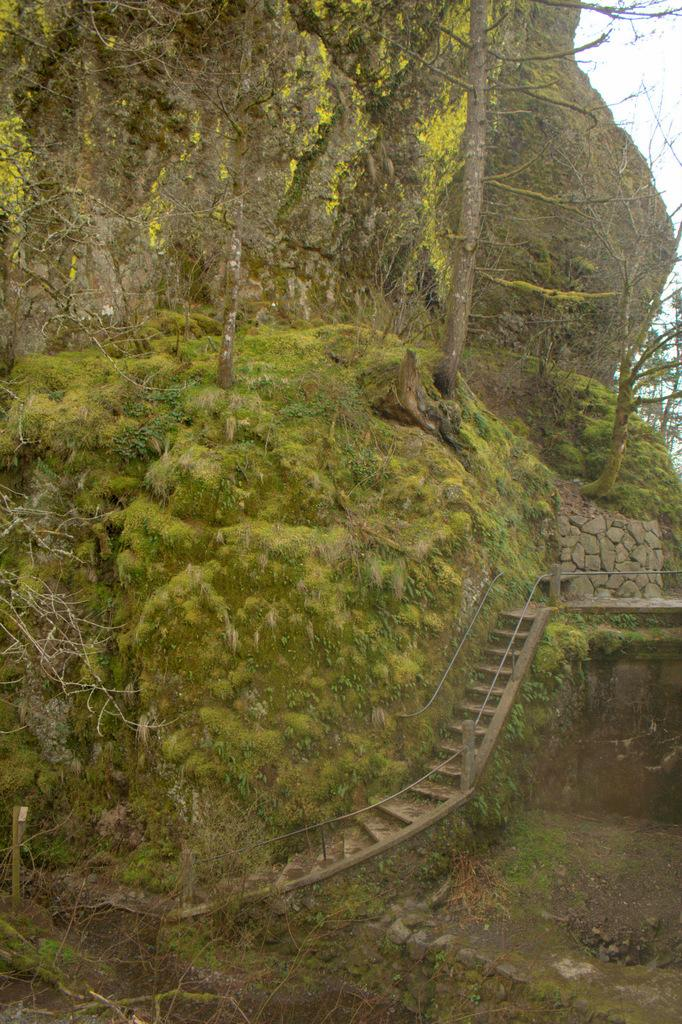What is the main subject of the image? The main subject of the image is a hill. What type of vegetation is present on the hill? There are green trees on the hill. What architectural feature can be seen on the hill? There is a staircase in the middle of the hill. What type of wax can be seen dripping from the trees on the hill? There is no wax present or depicted as dripping from the trees on the hill in the image. 